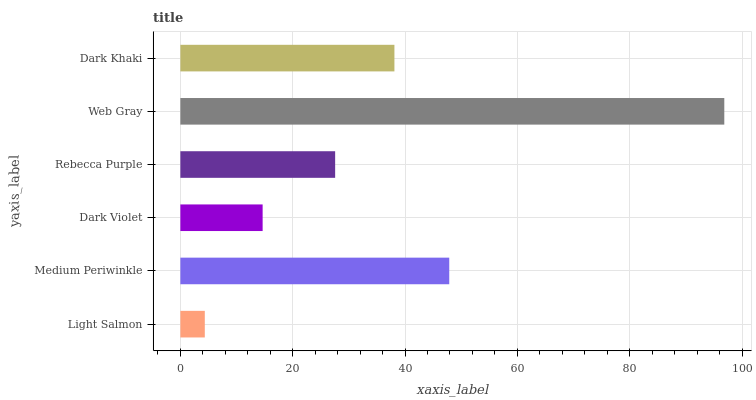Is Light Salmon the minimum?
Answer yes or no. Yes. Is Web Gray the maximum?
Answer yes or no. Yes. Is Medium Periwinkle the minimum?
Answer yes or no. No. Is Medium Periwinkle the maximum?
Answer yes or no. No. Is Medium Periwinkle greater than Light Salmon?
Answer yes or no. Yes. Is Light Salmon less than Medium Periwinkle?
Answer yes or no. Yes. Is Light Salmon greater than Medium Periwinkle?
Answer yes or no. No. Is Medium Periwinkle less than Light Salmon?
Answer yes or no. No. Is Dark Khaki the high median?
Answer yes or no. Yes. Is Rebecca Purple the low median?
Answer yes or no. Yes. Is Medium Periwinkle the high median?
Answer yes or no. No. Is Light Salmon the low median?
Answer yes or no. No. 